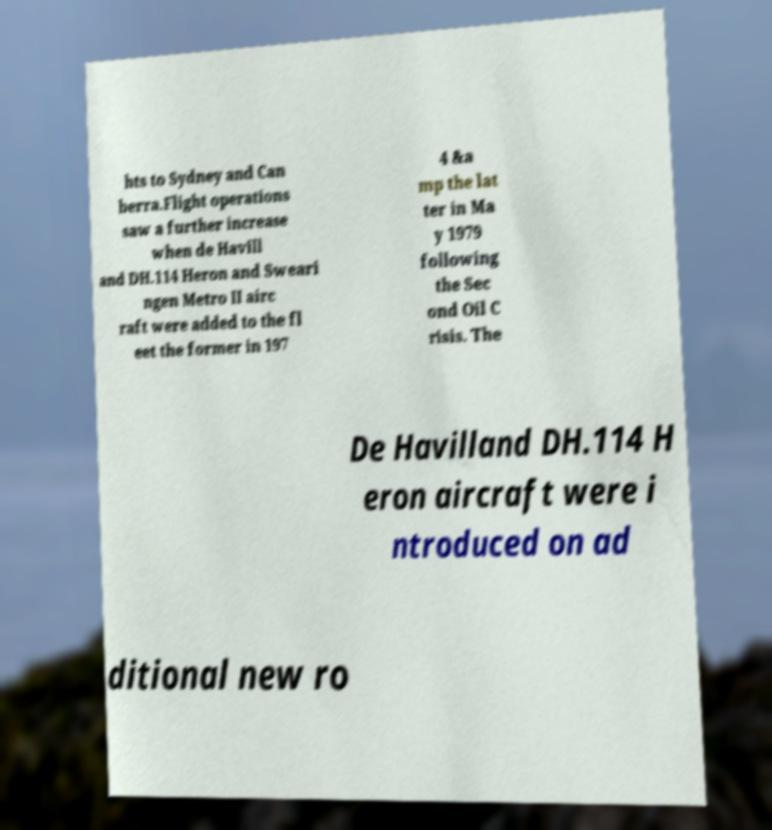What messages or text are displayed in this image? I need them in a readable, typed format. hts to Sydney and Can berra.Flight operations saw a further increase when de Havill and DH.114 Heron and Sweari ngen Metro II airc raft were added to the fl eet the former in 197 4 &a mp the lat ter in Ma y 1979 following the Sec ond Oil C risis. The De Havilland DH.114 H eron aircraft were i ntroduced on ad ditional new ro 